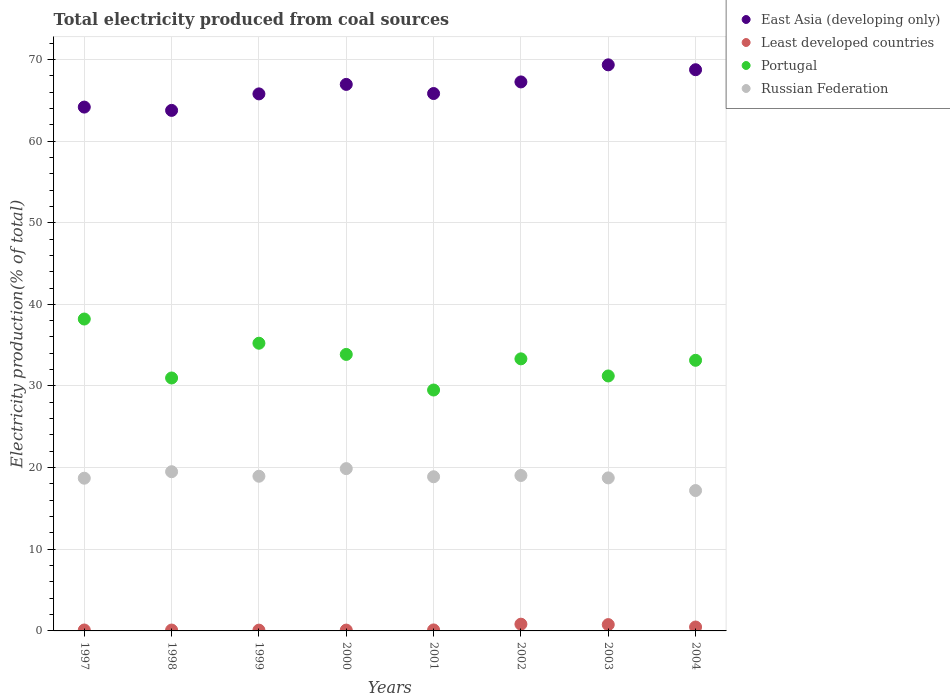How many different coloured dotlines are there?
Give a very brief answer. 4. What is the total electricity produced in Russian Federation in 2003?
Offer a terse response. 18.74. Across all years, what is the maximum total electricity produced in Russian Federation?
Your response must be concise. 19.88. Across all years, what is the minimum total electricity produced in Russian Federation?
Give a very brief answer. 17.19. In which year was the total electricity produced in Russian Federation maximum?
Make the answer very short. 2000. In which year was the total electricity produced in Portugal minimum?
Your response must be concise. 2001. What is the total total electricity produced in Portugal in the graph?
Your response must be concise. 265.48. What is the difference between the total electricity produced in Russian Federation in 1997 and that in 2001?
Ensure brevity in your answer.  -0.18. What is the difference between the total electricity produced in Portugal in 2002 and the total electricity produced in Russian Federation in 2000?
Provide a short and direct response. 13.45. What is the average total electricity produced in Least developed countries per year?
Give a very brief answer. 0.33. In the year 2000, what is the difference between the total electricity produced in East Asia (developing only) and total electricity produced in Least developed countries?
Provide a short and direct response. 66.84. In how many years, is the total electricity produced in Russian Federation greater than 66 %?
Give a very brief answer. 0. What is the ratio of the total electricity produced in Least developed countries in 2003 to that in 2004?
Your answer should be very brief. 1.62. What is the difference between the highest and the second highest total electricity produced in Least developed countries?
Offer a terse response. 0.05. What is the difference between the highest and the lowest total electricity produced in Portugal?
Offer a very short reply. 8.7. Is it the case that in every year, the sum of the total electricity produced in Least developed countries and total electricity produced in East Asia (developing only)  is greater than the sum of total electricity produced in Portugal and total electricity produced in Russian Federation?
Keep it short and to the point. Yes. Is it the case that in every year, the sum of the total electricity produced in East Asia (developing only) and total electricity produced in Portugal  is greater than the total electricity produced in Russian Federation?
Give a very brief answer. Yes. Does the total electricity produced in Portugal monotonically increase over the years?
Provide a short and direct response. No. Is the total electricity produced in Russian Federation strictly less than the total electricity produced in Portugal over the years?
Give a very brief answer. Yes. How many years are there in the graph?
Make the answer very short. 8. Are the values on the major ticks of Y-axis written in scientific E-notation?
Your answer should be compact. No. How are the legend labels stacked?
Give a very brief answer. Vertical. What is the title of the graph?
Provide a short and direct response. Total electricity produced from coal sources. Does "Niger" appear as one of the legend labels in the graph?
Offer a terse response. No. What is the label or title of the X-axis?
Offer a terse response. Years. What is the label or title of the Y-axis?
Give a very brief answer. Electricity production(% of total). What is the Electricity production(% of total) in East Asia (developing only) in 1997?
Offer a terse response. 64.16. What is the Electricity production(% of total) in Least developed countries in 1997?
Provide a short and direct response. 0.11. What is the Electricity production(% of total) of Portugal in 1997?
Offer a terse response. 38.2. What is the Electricity production(% of total) of Russian Federation in 1997?
Your answer should be very brief. 18.7. What is the Electricity production(% of total) in East Asia (developing only) in 1998?
Provide a short and direct response. 63.75. What is the Electricity production(% of total) of Least developed countries in 1998?
Ensure brevity in your answer.  0.11. What is the Electricity production(% of total) of Portugal in 1998?
Make the answer very short. 30.98. What is the Electricity production(% of total) of Russian Federation in 1998?
Ensure brevity in your answer.  19.5. What is the Electricity production(% of total) of East Asia (developing only) in 1999?
Ensure brevity in your answer.  65.77. What is the Electricity production(% of total) in Least developed countries in 1999?
Offer a very short reply. 0.1. What is the Electricity production(% of total) in Portugal in 1999?
Your answer should be compact. 35.24. What is the Electricity production(% of total) in Russian Federation in 1999?
Your answer should be compact. 18.94. What is the Electricity production(% of total) in East Asia (developing only) in 2000?
Make the answer very short. 66.94. What is the Electricity production(% of total) of Least developed countries in 2000?
Keep it short and to the point. 0.1. What is the Electricity production(% of total) in Portugal in 2000?
Keep it short and to the point. 33.87. What is the Electricity production(% of total) of Russian Federation in 2000?
Provide a succinct answer. 19.88. What is the Electricity production(% of total) in East Asia (developing only) in 2001?
Offer a very short reply. 65.82. What is the Electricity production(% of total) in Least developed countries in 2001?
Make the answer very short. 0.12. What is the Electricity production(% of total) of Portugal in 2001?
Provide a succinct answer. 29.51. What is the Electricity production(% of total) in Russian Federation in 2001?
Your answer should be compact. 18.88. What is the Electricity production(% of total) in East Asia (developing only) in 2002?
Keep it short and to the point. 67.24. What is the Electricity production(% of total) in Least developed countries in 2002?
Make the answer very short. 0.83. What is the Electricity production(% of total) of Portugal in 2002?
Offer a very short reply. 33.32. What is the Electricity production(% of total) in Russian Federation in 2002?
Make the answer very short. 19.04. What is the Electricity production(% of total) of East Asia (developing only) in 2003?
Make the answer very short. 69.33. What is the Electricity production(% of total) of Least developed countries in 2003?
Ensure brevity in your answer.  0.77. What is the Electricity production(% of total) of Portugal in 2003?
Your response must be concise. 31.23. What is the Electricity production(% of total) in Russian Federation in 2003?
Your answer should be compact. 18.74. What is the Electricity production(% of total) of East Asia (developing only) in 2004?
Provide a short and direct response. 68.73. What is the Electricity production(% of total) of Least developed countries in 2004?
Offer a very short reply. 0.48. What is the Electricity production(% of total) in Portugal in 2004?
Make the answer very short. 33.15. What is the Electricity production(% of total) of Russian Federation in 2004?
Provide a short and direct response. 17.19. Across all years, what is the maximum Electricity production(% of total) of East Asia (developing only)?
Your answer should be very brief. 69.33. Across all years, what is the maximum Electricity production(% of total) of Least developed countries?
Give a very brief answer. 0.83. Across all years, what is the maximum Electricity production(% of total) in Portugal?
Your answer should be compact. 38.2. Across all years, what is the maximum Electricity production(% of total) of Russian Federation?
Ensure brevity in your answer.  19.88. Across all years, what is the minimum Electricity production(% of total) of East Asia (developing only)?
Your answer should be compact. 63.75. Across all years, what is the minimum Electricity production(% of total) of Least developed countries?
Make the answer very short. 0.1. Across all years, what is the minimum Electricity production(% of total) of Portugal?
Your answer should be very brief. 29.51. Across all years, what is the minimum Electricity production(% of total) in Russian Federation?
Provide a short and direct response. 17.19. What is the total Electricity production(% of total) of East Asia (developing only) in the graph?
Provide a short and direct response. 531.75. What is the total Electricity production(% of total) of Least developed countries in the graph?
Your answer should be very brief. 2.62. What is the total Electricity production(% of total) in Portugal in the graph?
Ensure brevity in your answer.  265.48. What is the total Electricity production(% of total) in Russian Federation in the graph?
Keep it short and to the point. 150.88. What is the difference between the Electricity production(% of total) of East Asia (developing only) in 1997 and that in 1998?
Provide a succinct answer. 0.4. What is the difference between the Electricity production(% of total) of Least developed countries in 1997 and that in 1998?
Make the answer very short. 0.01. What is the difference between the Electricity production(% of total) in Portugal in 1997 and that in 1998?
Ensure brevity in your answer.  7.22. What is the difference between the Electricity production(% of total) of Russian Federation in 1997 and that in 1998?
Provide a succinct answer. -0.79. What is the difference between the Electricity production(% of total) of East Asia (developing only) in 1997 and that in 1999?
Your response must be concise. -1.62. What is the difference between the Electricity production(% of total) in Least developed countries in 1997 and that in 1999?
Ensure brevity in your answer.  0.02. What is the difference between the Electricity production(% of total) in Portugal in 1997 and that in 1999?
Offer a terse response. 2.96. What is the difference between the Electricity production(% of total) in Russian Federation in 1997 and that in 1999?
Offer a very short reply. -0.24. What is the difference between the Electricity production(% of total) of East Asia (developing only) in 1997 and that in 2000?
Offer a very short reply. -2.78. What is the difference between the Electricity production(% of total) in Least developed countries in 1997 and that in 2000?
Give a very brief answer. 0.01. What is the difference between the Electricity production(% of total) of Portugal in 1997 and that in 2000?
Provide a succinct answer. 4.34. What is the difference between the Electricity production(% of total) of Russian Federation in 1997 and that in 2000?
Give a very brief answer. -1.17. What is the difference between the Electricity production(% of total) in East Asia (developing only) in 1997 and that in 2001?
Your answer should be very brief. -1.66. What is the difference between the Electricity production(% of total) of Least developed countries in 1997 and that in 2001?
Your response must be concise. -0.01. What is the difference between the Electricity production(% of total) in Portugal in 1997 and that in 2001?
Give a very brief answer. 8.7. What is the difference between the Electricity production(% of total) of Russian Federation in 1997 and that in 2001?
Your answer should be very brief. -0.18. What is the difference between the Electricity production(% of total) of East Asia (developing only) in 1997 and that in 2002?
Give a very brief answer. -3.08. What is the difference between the Electricity production(% of total) in Least developed countries in 1997 and that in 2002?
Offer a terse response. -0.71. What is the difference between the Electricity production(% of total) of Portugal in 1997 and that in 2002?
Keep it short and to the point. 4.88. What is the difference between the Electricity production(% of total) of Russian Federation in 1997 and that in 2002?
Keep it short and to the point. -0.33. What is the difference between the Electricity production(% of total) of East Asia (developing only) in 1997 and that in 2003?
Your answer should be compact. -5.17. What is the difference between the Electricity production(% of total) of Least developed countries in 1997 and that in 2003?
Your answer should be very brief. -0.66. What is the difference between the Electricity production(% of total) of Portugal in 1997 and that in 2003?
Your answer should be compact. 6.97. What is the difference between the Electricity production(% of total) in Russian Federation in 1997 and that in 2003?
Provide a succinct answer. -0.04. What is the difference between the Electricity production(% of total) of East Asia (developing only) in 1997 and that in 2004?
Keep it short and to the point. -4.58. What is the difference between the Electricity production(% of total) in Least developed countries in 1997 and that in 2004?
Give a very brief answer. -0.36. What is the difference between the Electricity production(% of total) of Portugal in 1997 and that in 2004?
Offer a terse response. 5.06. What is the difference between the Electricity production(% of total) of Russian Federation in 1997 and that in 2004?
Provide a short and direct response. 1.51. What is the difference between the Electricity production(% of total) of East Asia (developing only) in 1998 and that in 1999?
Your answer should be very brief. -2.02. What is the difference between the Electricity production(% of total) in Least developed countries in 1998 and that in 1999?
Your response must be concise. 0.01. What is the difference between the Electricity production(% of total) of Portugal in 1998 and that in 1999?
Make the answer very short. -4.26. What is the difference between the Electricity production(% of total) in Russian Federation in 1998 and that in 1999?
Provide a succinct answer. 0.55. What is the difference between the Electricity production(% of total) in East Asia (developing only) in 1998 and that in 2000?
Offer a very short reply. -3.18. What is the difference between the Electricity production(% of total) in Least developed countries in 1998 and that in 2000?
Offer a very short reply. 0. What is the difference between the Electricity production(% of total) in Portugal in 1998 and that in 2000?
Your response must be concise. -2.89. What is the difference between the Electricity production(% of total) in Russian Federation in 1998 and that in 2000?
Offer a very short reply. -0.38. What is the difference between the Electricity production(% of total) of East Asia (developing only) in 1998 and that in 2001?
Provide a succinct answer. -2.07. What is the difference between the Electricity production(% of total) of Least developed countries in 1998 and that in 2001?
Your response must be concise. -0.02. What is the difference between the Electricity production(% of total) of Portugal in 1998 and that in 2001?
Ensure brevity in your answer.  1.47. What is the difference between the Electricity production(% of total) in Russian Federation in 1998 and that in 2001?
Provide a succinct answer. 0.62. What is the difference between the Electricity production(% of total) of East Asia (developing only) in 1998 and that in 2002?
Your response must be concise. -3.49. What is the difference between the Electricity production(% of total) of Least developed countries in 1998 and that in 2002?
Your answer should be compact. -0.72. What is the difference between the Electricity production(% of total) of Portugal in 1998 and that in 2002?
Provide a succinct answer. -2.34. What is the difference between the Electricity production(% of total) of Russian Federation in 1998 and that in 2002?
Provide a succinct answer. 0.46. What is the difference between the Electricity production(% of total) of East Asia (developing only) in 1998 and that in 2003?
Your answer should be compact. -5.58. What is the difference between the Electricity production(% of total) of Least developed countries in 1998 and that in 2003?
Offer a terse response. -0.67. What is the difference between the Electricity production(% of total) in Portugal in 1998 and that in 2003?
Provide a succinct answer. -0.25. What is the difference between the Electricity production(% of total) in Russian Federation in 1998 and that in 2003?
Offer a very short reply. 0.76. What is the difference between the Electricity production(% of total) of East Asia (developing only) in 1998 and that in 2004?
Your answer should be compact. -4.98. What is the difference between the Electricity production(% of total) of Least developed countries in 1998 and that in 2004?
Make the answer very short. -0.37. What is the difference between the Electricity production(% of total) in Portugal in 1998 and that in 2004?
Your response must be concise. -2.17. What is the difference between the Electricity production(% of total) in Russian Federation in 1998 and that in 2004?
Your answer should be compact. 2.31. What is the difference between the Electricity production(% of total) in East Asia (developing only) in 1999 and that in 2000?
Your answer should be very brief. -1.16. What is the difference between the Electricity production(% of total) of Least developed countries in 1999 and that in 2000?
Your answer should be compact. -0.01. What is the difference between the Electricity production(% of total) in Portugal in 1999 and that in 2000?
Give a very brief answer. 1.37. What is the difference between the Electricity production(% of total) in Russian Federation in 1999 and that in 2000?
Offer a terse response. -0.93. What is the difference between the Electricity production(% of total) of East Asia (developing only) in 1999 and that in 2001?
Give a very brief answer. -0.04. What is the difference between the Electricity production(% of total) of Least developed countries in 1999 and that in 2001?
Your answer should be very brief. -0.02. What is the difference between the Electricity production(% of total) in Portugal in 1999 and that in 2001?
Make the answer very short. 5.73. What is the difference between the Electricity production(% of total) in Russian Federation in 1999 and that in 2001?
Make the answer very short. 0.06. What is the difference between the Electricity production(% of total) in East Asia (developing only) in 1999 and that in 2002?
Offer a terse response. -1.47. What is the difference between the Electricity production(% of total) in Least developed countries in 1999 and that in 2002?
Offer a very short reply. -0.73. What is the difference between the Electricity production(% of total) in Portugal in 1999 and that in 2002?
Provide a succinct answer. 1.91. What is the difference between the Electricity production(% of total) of Russian Federation in 1999 and that in 2002?
Give a very brief answer. -0.09. What is the difference between the Electricity production(% of total) of East Asia (developing only) in 1999 and that in 2003?
Provide a succinct answer. -3.56. What is the difference between the Electricity production(% of total) in Least developed countries in 1999 and that in 2003?
Your response must be concise. -0.68. What is the difference between the Electricity production(% of total) of Portugal in 1999 and that in 2003?
Offer a terse response. 4.01. What is the difference between the Electricity production(% of total) in Russian Federation in 1999 and that in 2003?
Provide a succinct answer. 0.2. What is the difference between the Electricity production(% of total) of East Asia (developing only) in 1999 and that in 2004?
Your response must be concise. -2.96. What is the difference between the Electricity production(% of total) of Least developed countries in 1999 and that in 2004?
Offer a very short reply. -0.38. What is the difference between the Electricity production(% of total) in Portugal in 1999 and that in 2004?
Your answer should be compact. 2.09. What is the difference between the Electricity production(% of total) of Russian Federation in 1999 and that in 2004?
Offer a terse response. 1.75. What is the difference between the Electricity production(% of total) of East Asia (developing only) in 2000 and that in 2001?
Offer a terse response. 1.12. What is the difference between the Electricity production(% of total) in Least developed countries in 2000 and that in 2001?
Your response must be concise. -0.02. What is the difference between the Electricity production(% of total) of Portugal in 2000 and that in 2001?
Offer a very short reply. 4.36. What is the difference between the Electricity production(% of total) in Russian Federation in 2000 and that in 2001?
Provide a short and direct response. 1. What is the difference between the Electricity production(% of total) of East Asia (developing only) in 2000 and that in 2002?
Make the answer very short. -0.3. What is the difference between the Electricity production(% of total) of Least developed countries in 2000 and that in 2002?
Ensure brevity in your answer.  -0.72. What is the difference between the Electricity production(% of total) of Portugal in 2000 and that in 2002?
Keep it short and to the point. 0.54. What is the difference between the Electricity production(% of total) in Russian Federation in 2000 and that in 2002?
Your answer should be compact. 0.84. What is the difference between the Electricity production(% of total) in East Asia (developing only) in 2000 and that in 2003?
Offer a very short reply. -2.4. What is the difference between the Electricity production(% of total) in Least developed countries in 2000 and that in 2003?
Your answer should be very brief. -0.67. What is the difference between the Electricity production(% of total) of Portugal in 2000 and that in 2003?
Provide a succinct answer. 2.64. What is the difference between the Electricity production(% of total) in Russian Federation in 2000 and that in 2003?
Give a very brief answer. 1.14. What is the difference between the Electricity production(% of total) in East Asia (developing only) in 2000 and that in 2004?
Give a very brief answer. -1.8. What is the difference between the Electricity production(% of total) in Least developed countries in 2000 and that in 2004?
Offer a terse response. -0.38. What is the difference between the Electricity production(% of total) of Portugal in 2000 and that in 2004?
Provide a short and direct response. 0.72. What is the difference between the Electricity production(% of total) of Russian Federation in 2000 and that in 2004?
Provide a succinct answer. 2.68. What is the difference between the Electricity production(% of total) in East Asia (developing only) in 2001 and that in 2002?
Provide a succinct answer. -1.42. What is the difference between the Electricity production(% of total) of Least developed countries in 2001 and that in 2002?
Give a very brief answer. -0.71. What is the difference between the Electricity production(% of total) in Portugal in 2001 and that in 2002?
Your answer should be compact. -3.82. What is the difference between the Electricity production(% of total) in Russian Federation in 2001 and that in 2002?
Your response must be concise. -0.16. What is the difference between the Electricity production(% of total) in East Asia (developing only) in 2001 and that in 2003?
Offer a very short reply. -3.51. What is the difference between the Electricity production(% of total) of Least developed countries in 2001 and that in 2003?
Offer a terse response. -0.65. What is the difference between the Electricity production(% of total) of Portugal in 2001 and that in 2003?
Offer a very short reply. -1.72. What is the difference between the Electricity production(% of total) in Russian Federation in 2001 and that in 2003?
Your answer should be compact. 0.14. What is the difference between the Electricity production(% of total) in East Asia (developing only) in 2001 and that in 2004?
Offer a terse response. -2.91. What is the difference between the Electricity production(% of total) in Least developed countries in 2001 and that in 2004?
Offer a terse response. -0.36. What is the difference between the Electricity production(% of total) of Portugal in 2001 and that in 2004?
Provide a short and direct response. -3.64. What is the difference between the Electricity production(% of total) in Russian Federation in 2001 and that in 2004?
Provide a succinct answer. 1.69. What is the difference between the Electricity production(% of total) in East Asia (developing only) in 2002 and that in 2003?
Ensure brevity in your answer.  -2.09. What is the difference between the Electricity production(% of total) in Least developed countries in 2002 and that in 2003?
Your answer should be compact. 0.05. What is the difference between the Electricity production(% of total) of Portugal in 2002 and that in 2003?
Offer a terse response. 2.1. What is the difference between the Electricity production(% of total) in Russian Federation in 2002 and that in 2003?
Offer a terse response. 0.3. What is the difference between the Electricity production(% of total) in East Asia (developing only) in 2002 and that in 2004?
Your answer should be compact. -1.49. What is the difference between the Electricity production(% of total) in Least developed countries in 2002 and that in 2004?
Your answer should be very brief. 0.35. What is the difference between the Electricity production(% of total) of Portugal in 2002 and that in 2004?
Give a very brief answer. 0.18. What is the difference between the Electricity production(% of total) in Russian Federation in 2002 and that in 2004?
Ensure brevity in your answer.  1.85. What is the difference between the Electricity production(% of total) of East Asia (developing only) in 2003 and that in 2004?
Provide a succinct answer. 0.6. What is the difference between the Electricity production(% of total) of Least developed countries in 2003 and that in 2004?
Your answer should be compact. 0.3. What is the difference between the Electricity production(% of total) in Portugal in 2003 and that in 2004?
Offer a very short reply. -1.92. What is the difference between the Electricity production(% of total) in Russian Federation in 2003 and that in 2004?
Your response must be concise. 1.55. What is the difference between the Electricity production(% of total) of East Asia (developing only) in 1997 and the Electricity production(% of total) of Least developed countries in 1998?
Offer a very short reply. 64.05. What is the difference between the Electricity production(% of total) in East Asia (developing only) in 1997 and the Electricity production(% of total) in Portugal in 1998?
Give a very brief answer. 33.18. What is the difference between the Electricity production(% of total) of East Asia (developing only) in 1997 and the Electricity production(% of total) of Russian Federation in 1998?
Your answer should be very brief. 44.66. What is the difference between the Electricity production(% of total) of Least developed countries in 1997 and the Electricity production(% of total) of Portugal in 1998?
Your response must be concise. -30.87. What is the difference between the Electricity production(% of total) of Least developed countries in 1997 and the Electricity production(% of total) of Russian Federation in 1998?
Ensure brevity in your answer.  -19.39. What is the difference between the Electricity production(% of total) of Portugal in 1997 and the Electricity production(% of total) of Russian Federation in 1998?
Your answer should be compact. 18.7. What is the difference between the Electricity production(% of total) of East Asia (developing only) in 1997 and the Electricity production(% of total) of Least developed countries in 1999?
Keep it short and to the point. 64.06. What is the difference between the Electricity production(% of total) in East Asia (developing only) in 1997 and the Electricity production(% of total) in Portugal in 1999?
Your answer should be very brief. 28.92. What is the difference between the Electricity production(% of total) of East Asia (developing only) in 1997 and the Electricity production(% of total) of Russian Federation in 1999?
Make the answer very short. 45.21. What is the difference between the Electricity production(% of total) in Least developed countries in 1997 and the Electricity production(% of total) in Portugal in 1999?
Make the answer very short. -35.12. What is the difference between the Electricity production(% of total) of Least developed countries in 1997 and the Electricity production(% of total) of Russian Federation in 1999?
Offer a terse response. -18.83. What is the difference between the Electricity production(% of total) in Portugal in 1997 and the Electricity production(% of total) in Russian Federation in 1999?
Provide a short and direct response. 19.26. What is the difference between the Electricity production(% of total) of East Asia (developing only) in 1997 and the Electricity production(% of total) of Least developed countries in 2000?
Your answer should be compact. 64.06. What is the difference between the Electricity production(% of total) in East Asia (developing only) in 1997 and the Electricity production(% of total) in Portugal in 2000?
Ensure brevity in your answer.  30.29. What is the difference between the Electricity production(% of total) in East Asia (developing only) in 1997 and the Electricity production(% of total) in Russian Federation in 2000?
Give a very brief answer. 44.28. What is the difference between the Electricity production(% of total) in Least developed countries in 1997 and the Electricity production(% of total) in Portugal in 2000?
Your answer should be compact. -33.75. What is the difference between the Electricity production(% of total) in Least developed countries in 1997 and the Electricity production(% of total) in Russian Federation in 2000?
Your answer should be very brief. -19.76. What is the difference between the Electricity production(% of total) in Portugal in 1997 and the Electricity production(% of total) in Russian Federation in 2000?
Ensure brevity in your answer.  18.32. What is the difference between the Electricity production(% of total) in East Asia (developing only) in 1997 and the Electricity production(% of total) in Least developed countries in 2001?
Make the answer very short. 64.04. What is the difference between the Electricity production(% of total) of East Asia (developing only) in 1997 and the Electricity production(% of total) of Portugal in 2001?
Offer a terse response. 34.65. What is the difference between the Electricity production(% of total) in East Asia (developing only) in 1997 and the Electricity production(% of total) in Russian Federation in 2001?
Make the answer very short. 45.28. What is the difference between the Electricity production(% of total) of Least developed countries in 1997 and the Electricity production(% of total) of Portugal in 2001?
Your response must be concise. -29.39. What is the difference between the Electricity production(% of total) of Least developed countries in 1997 and the Electricity production(% of total) of Russian Federation in 2001?
Provide a short and direct response. -18.77. What is the difference between the Electricity production(% of total) of Portugal in 1997 and the Electricity production(% of total) of Russian Federation in 2001?
Offer a very short reply. 19.32. What is the difference between the Electricity production(% of total) in East Asia (developing only) in 1997 and the Electricity production(% of total) in Least developed countries in 2002?
Your answer should be compact. 63.33. What is the difference between the Electricity production(% of total) in East Asia (developing only) in 1997 and the Electricity production(% of total) in Portugal in 2002?
Offer a terse response. 30.84. What is the difference between the Electricity production(% of total) in East Asia (developing only) in 1997 and the Electricity production(% of total) in Russian Federation in 2002?
Offer a very short reply. 45.12. What is the difference between the Electricity production(% of total) in Least developed countries in 1997 and the Electricity production(% of total) in Portugal in 2002?
Provide a succinct answer. -33.21. What is the difference between the Electricity production(% of total) of Least developed countries in 1997 and the Electricity production(% of total) of Russian Federation in 2002?
Your answer should be compact. -18.93. What is the difference between the Electricity production(% of total) of Portugal in 1997 and the Electricity production(% of total) of Russian Federation in 2002?
Your answer should be very brief. 19.16. What is the difference between the Electricity production(% of total) in East Asia (developing only) in 1997 and the Electricity production(% of total) in Least developed countries in 2003?
Offer a very short reply. 63.38. What is the difference between the Electricity production(% of total) of East Asia (developing only) in 1997 and the Electricity production(% of total) of Portugal in 2003?
Offer a very short reply. 32.93. What is the difference between the Electricity production(% of total) in East Asia (developing only) in 1997 and the Electricity production(% of total) in Russian Federation in 2003?
Offer a very short reply. 45.42. What is the difference between the Electricity production(% of total) in Least developed countries in 1997 and the Electricity production(% of total) in Portugal in 2003?
Your answer should be compact. -31.11. What is the difference between the Electricity production(% of total) in Least developed countries in 1997 and the Electricity production(% of total) in Russian Federation in 2003?
Provide a succinct answer. -18.63. What is the difference between the Electricity production(% of total) in Portugal in 1997 and the Electricity production(% of total) in Russian Federation in 2003?
Provide a short and direct response. 19.46. What is the difference between the Electricity production(% of total) of East Asia (developing only) in 1997 and the Electricity production(% of total) of Least developed countries in 2004?
Offer a terse response. 63.68. What is the difference between the Electricity production(% of total) of East Asia (developing only) in 1997 and the Electricity production(% of total) of Portugal in 2004?
Provide a succinct answer. 31.01. What is the difference between the Electricity production(% of total) in East Asia (developing only) in 1997 and the Electricity production(% of total) in Russian Federation in 2004?
Make the answer very short. 46.97. What is the difference between the Electricity production(% of total) of Least developed countries in 1997 and the Electricity production(% of total) of Portugal in 2004?
Offer a terse response. -33.03. What is the difference between the Electricity production(% of total) of Least developed countries in 1997 and the Electricity production(% of total) of Russian Federation in 2004?
Offer a very short reply. -17.08. What is the difference between the Electricity production(% of total) of Portugal in 1997 and the Electricity production(% of total) of Russian Federation in 2004?
Provide a succinct answer. 21.01. What is the difference between the Electricity production(% of total) of East Asia (developing only) in 1998 and the Electricity production(% of total) of Least developed countries in 1999?
Your answer should be very brief. 63.66. What is the difference between the Electricity production(% of total) of East Asia (developing only) in 1998 and the Electricity production(% of total) of Portugal in 1999?
Keep it short and to the point. 28.52. What is the difference between the Electricity production(% of total) in East Asia (developing only) in 1998 and the Electricity production(% of total) in Russian Federation in 1999?
Offer a terse response. 44.81. What is the difference between the Electricity production(% of total) in Least developed countries in 1998 and the Electricity production(% of total) in Portugal in 1999?
Ensure brevity in your answer.  -35.13. What is the difference between the Electricity production(% of total) of Least developed countries in 1998 and the Electricity production(% of total) of Russian Federation in 1999?
Offer a terse response. -18.84. What is the difference between the Electricity production(% of total) in Portugal in 1998 and the Electricity production(% of total) in Russian Federation in 1999?
Your answer should be compact. 12.03. What is the difference between the Electricity production(% of total) of East Asia (developing only) in 1998 and the Electricity production(% of total) of Least developed countries in 2000?
Ensure brevity in your answer.  63.65. What is the difference between the Electricity production(% of total) in East Asia (developing only) in 1998 and the Electricity production(% of total) in Portugal in 2000?
Your answer should be very brief. 29.89. What is the difference between the Electricity production(% of total) in East Asia (developing only) in 1998 and the Electricity production(% of total) in Russian Federation in 2000?
Your answer should be very brief. 43.88. What is the difference between the Electricity production(% of total) in Least developed countries in 1998 and the Electricity production(% of total) in Portugal in 2000?
Keep it short and to the point. -33.76. What is the difference between the Electricity production(% of total) of Least developed countries in 1998 and the Electricity production(% of total) of Russian Federation in 2000?
Provide a succinct answer. -19.77. What is the difference between the Electricity production(% of total) in Portugal in 1998 and the Electricity production(% of total) in Russian Federation in 2000?
Make the answer very short. 11.1. What is the difference between the Electricity production(% of total) in East Asia (developing only) in 1998 and the Electricity production(% of total) in Least developed countries in 2001?
Offer a very short reply. 63.63. What is the difference between the Electricity production(% of total) of East Asia (developing only) in 1998 and the Electricity production(% of total) of Portugal in 2001?
Offer a very short reply. 34.25. What is the difference between the Electricity production(% of total) in East Asia (developing only) in 1998 and the Electricity production(% of total) in Russian Federation in 2001?
Provide a short and direct response. 44.87. What is the difference between the Electricity production(% of total) of Least developed countries in 1998 and the Electricity production(% of total) of Portugal in 2001?
Your answer should be very brief. -29.4. What is the difference between the Electricity production(% of total) of Least developed countries in 1998 and the Electricity production(% of total) of Russian Federation in 2001?
Ensure brevity in your answer.  -18.78. What is the difference between the Electricity production(% of total) of Portugal in 1998 and the Electricity production(% of total) of Russian Federation in 2001?
Ensure brevity in your answer.  12.1. What is the difference between the Electricity production(% of total) in East Asia (developing only) in 1998 and the Electricity production(% of total) in Least developed countries in 2002?
Offer a very short reply. 62.93. What is the difference between the Electricity production(% of total) of East Asia (developing only) in 1998 and the Electricity production(% of total) of Portugal in 2002?
Your response must be concise. 30.43. What is the difference between the Electricity production(% of total) of East Asia (developing only) in 1998 and the Electricity production(% of total) of Russian Federation in 2002?
Make the answer very short. 44.71. What is the difference between the Electricity production(% of total) of Least developed countries in 1998 and the Electricity production(% of total) of Portugal in 2002?
Ensure brevity in your answer.  -33.22. What is the difference between the Electricity production(% of total) in Least developed countries in 1998 and the Electricity production(% of total) in Russian Federation in 2002?
Provide a succinct answer. -18.93. What is the difference between the Electricity production(% of total) of Portugal in 1998 and the Electricity production(% of total) of Russian Federation in 2002?
Ensure brevity in your answer.  11.94. What is the difference between the Electricity production(% of total) of East Asia (developing only) in 1998 and the Electricity production(% of total) of Least developed countries in 2003?
Make the answer very short. 62.98. What is the difference between the Electricity production(% of total) in East Asia (developing only) in 1998 and the Electricity production(% of total) in Portugal in 2003?
Provide a short and direct response. 32.53. What is the difference between the Electricity production(% of total) of East Asia (developing only) in 1998 and the Electricity production(% of total) of Russian Federation in 2003?
Provide a short and direct response. 45.01. What is the difference between the Electricity production(% of total) in Least developed countries in 1998 and the Electricity production(% of total) in Portugal in 2003?
Make the answer very short. -31.12. What is the difference between the Electricity production(% of total) in Least developed countries in 1998 and the Electricity production(% of total) in Russian Federation in 2003?
Give a very brief answer. -18.64. What is the difference between the Electricity production(% of total) of Portugal in 1998 and the Electricity production(% of total) of Russian Federation in 2003?
Your answer should be compact. 12.24. What is the difference between the Electricity production(% of total) of East Asia (developing only) in 1998 and the Electricity production(% of total) of Least developed countries in 2004?
Your response must be concise. 63.28. What is the difference between the Electricity production(% of total) of East Asia (developing only) in 1998 and the Electricity production(% of total) of Portugal in 2004?
Keep it short and to the point. 30.61. What is the difference between the Electricity production(% of total) in East Asia (developing only) in 1998 and the Electricity production(% of total) in Russian Federation in 2004?
Ensure brevity in your answer.  46.56. What is the difference between the Electricity production(% of total) of Least developed countries in 1998 and the Electricity production(% of total) of Portugal in 2004?
Keep it short and to the point. -33.04. What is the difference between the Electricity production(% of total) in Least developed countries in 1998 and the Electricity production(% of total) in Russian Federation in 2004?
Your response must be concise. -17.09. What is the difference between the Electricity production(% of total) in Portugal in 1998 and the Electricity production(% of total) in Russian Federation in 2004?
Ensure brevity in your answer.  13.79. What is the difference between the Electricity production(% of total) of East Asia (developing only) in 1999 and the Electricity production(% of total) of Least developed countries in 2000?
Provide a short and direct response. 65.67. What is the difference between the Electricity production(% of total) of East Asia (developing only) in 1999 and the Electricity production(% of total) of Portugal in 2000?
Keep it short and to the point. 31.91. What is the difference between the Electricity production(% of total) in East Asia (developing only) in 1999 and the Electricity production(% of total) in Russian Federation in 2000?
Provide a short and direct response. 45.9. What is the difference between the Electricity production(% of total) in Least developed countries in 1999 and the Electricity production(% of total) in Portugal in 2000?
Give a very brief answer. -33.77. What is the difference between the Electricity production(% of total) in Least developed countries in 1999 and the Electricity production(% of total) in Russian Federation in 2000?
Provide a short and direct response. -19.78. What is the difference between the Electricity production(% of total) of Portugal in 1999 and the Electricity production(% of total) of Russian Federation in 2000?
Provide a succinct answer. 15.36. What is the difference between the Electricity production(% of total) in East Asia (developing only) in 1999 and the Electricity production(% of total) in Least developed countries in 2001?
Offer a terse response. 65.65. What is the difference between the Electricity production(% of total) of East Asia (developing only) in 1999 and the Electricity production(% of total) of Portugal in 2001?
Your answer should be very brief. 36.27. What is the difference between the Electricity production(% of total) of East Asia (developing only) in 1999 and the Electricity production(% of total) of Russian Federation in 2001?
Offer a very short reply. 46.89. What is the difference between the Electricity production(% of total) of Least developed countries in 1999 and the Electricity production(% of total) of Portugal in 2001?
Your answer should be very brief. -29.41. What is the difference between the Electricity production(% of total) in Least developed countries in 1999 and the Electricity production(% of total) in Russian Federation in 2001?
Offer a very short reply. -18.79. What is the difference between the Electricity production(% of total) in Portugal in 1999 and the Electricity production(% of total) in Russian Federation in 2001?
Provide a short and direct response. 16.35. What is the difference between the Electricity production(% of total) of East Asia (developing only) in 1999 and the Electricity production(% of total) of Least developed countries in 2002?
Provide a succinct answer. 64.95. What is the difference between the Electricity production(% of total) of East Asia (developing only) in 1999 and the Electricity production(% of total) of Portugal in 2002?
Give a very brief answer. 32.45. What is the difference between the Electricity production(% of total) in East Asia (developing only) in 1999 and the Electricity production(% of total) in Russian Federation in 2002?
Offer a terse response. 46.74. What is the difference between the Electricity production(% of total) of Least developed countries in 1999 and the Electricity production(% of total) of Portugal in 2002?
Your answer should be compact. -33.23. What is the difference between the Electricity production(% of total) in Least developed countries in 1999 and the Electricity production(% of total) in Russian Federation in 2002?
Provide a short and direct response. -18.94. What is the difference between the Electricity production(% of total) in Portugal in 1999 and the Electricity production(% of total) in Russian Federation in 2002?
Offer a very short reply. 16.2. What is the difference between the Electricity production(% of total) of East Asia (developing only) in 1999 and the Electricity production(% of total) of Least developed countries in 2003?
Ensure brevity in your answer.  65. What is the difference between the Electricity production(% of total) in East Asia (developing only) in 1999 and the Electricity production(% of total) in Portugal in 2003?
Keep it short and to the point. 34.55. What is the difference between the Electricity production(% of total) in East Asia (developing only) in 1999 and the Electricity production(% of total) in Russian Federation in 2003?
Offer a very short reply. 47.03. What is the difference between the Electricity production(% of total) in Least developed countries in 1999 and the Electricity production(% of total) in Portugal in 2003?
Make the answer very short. -31.13. What is the difference between the Electricity production(% of total) in Least developed countries in 1999 and the Electricity production(% of total) in Russian Federation in 2003?
Your answer should be compact. -18.64. What is the difference between the Electricity production(% of total) in Portugal in 1999 and the Electricity production(% of total) in Russian Federation in 2003?
Give a very brief answer. 16.49. What is the difference between the Electricity production(% of total) in East Asia (developing only) in 1999 and the Electricity production(% of total) in Least developed countries in 2004?
Your answer should be compact. 65.3. What is the difference between the Electricity production(% of total) in East Asia (developing only) in 1999 and the Electricity production(% of total) in Portugal in 2004?
Provide a short and direct response. 32.63. What is the difference between the Electricity production(% of total) of East Asia (developing only) in 1999 and the Electricity production(% of total) of Russian Federation in 2004?
Keep it short and to the point. 48.58. What is the difference between the Electricity production(% of total) in Least developed countries in 1999 and the Electricity production(% of total) in Portugal in 2004?
Make the answer very short. -33.05. What is the difference between the Electricity production(% of total) of Least developed countries in 1999 and the Electricity production(% of total) of Russian Federation in 2004?
Your response must be concise. -17.1. What is the difference between the Electricity production(% of total) in Portugal in 1999 and the Electricity production(% of total) in Russian Federation in 2004?
Make the answer very short. 18.04. What is the difference between the Electricity production(% of total) of East Asia (developing only) in 2000 and the Electricity production(% of total) of Least developed countries in 2001?
Keep it short and to the point. 66.82. What is the difference between the Electricity production(% of total) of East Asia (developing only) in 2000 and the Electricity production(% of total) of Portugal in 2001?
Your response must be concise. 37.43. What is the difference between the Electricity production(% of total) of East Asia (developing only) in 2000 and the Electricity production(% of total) of Russian Federation in 2001?
Make the answer very short. 48.05. What is the difference between the Electricity production(% of total) of Least developed countries in 2000 and the Electricity production(% of total) of Portugal in 2001?
Make the answer very short. -29.4. What is the difference between the Electricity production(% of total) of Least developed countries in 2000 and the Electricity production(% of total) of Russian Federation in 2001?
Give a very brief answer. -18.78. What is the difference between the Electricity production(% of total) in Portugal in 2000 and the Electricity production(% of total) in Russian Federation in 2001?
Provide a short and direct response. 14.98. What is the difference between the Electricity production(% of total) in East Asia (developing only) in 2000 and the Electricity production(% of total) in Least developed countries in 2002?
Give a very brief answer. 66.11. What is the difference between the Electricity production(% of total) of East Asia (developing only) in 2000 and the Electricity production(% of total) of Portugal in 2002?
Your answer should be compact. 33.61. What is the difference between the Electricity production(% of total) in East Asia (developing only) in 2000 and the Electricity production(% of total) in Russian Federation in 2002?
Provide a succinct answer. 47.9. What is the difference between the Electricity production(% of total) in Least developed countries in 2000 and the Electricity production(% of total) in Portugal in 2002?
Give a very brief answer. -33.22. What is the difference between the Electricity production(% of total) in Least developed countries in 2000 and the Electricity production(% of total) in Russian Federation in 2002?
Your response must be concise. -18.94. What is the difference between the Electricity production(% of total) of Portugal in 2000 and the Electricity production(% of total) of Russian Federation in 2002?
Your answer should be compact. 14.83. What is the difference between the Electricity production(% of total) in East Asia (developing only) in 2000 and the Electricity production(% of total) in Least developed countries in 2003?
Offer a terse response. 66.16. What is the difference between the Electricity production(% of total) of East Asia (developing only) in 2000 and the Electricity production(% of total) of Portugal in 2003?
Provide a short and direct response. 35.71. What is the difference between the Electricity production(% of total) in East Asia (developing only) in 2000 and the Electricity production(% of total) in Russian Federation in 2003?
Your response must be concise. 48.2. What is the difference between the Electricity production(% of total) of Least developed countries in 2000 and the Electricity production(% of total) of Portugal in 2003?
Provide a succinct answer. -31.13. What is the difference between the Electricity production(% of total) of Least developed countries in 2000 and the Electricity production(% of total) of Russian Federation in 2003?
Give a very brief answer. -18.64. What is the difference between the Electricity production(% of total) in Portugal in 2000 and the Electricity production(% of total) in Russian Federation in 2003?
Your answer should be very brief. 15.12. What is the difference between the Electricity production(% of total) in East Asia (developing only) in 2000 and the Electricity production(% of total) in Least developed countries in 2004?
Offer a terse response. 66.46. What is the difference between the Electricity production(% of total) in East Asia (developing only) in 2000 and the Electricity production(% of total) in Portugal in 2004?
Your response must be concise. 33.79. What is the difference between the Electricity production(% of total) of East Asia (developing only) in 2000 and the Electricity production(% of total) of Russian Federation in 2004?
Provide a succinct answer. 49.74. What is the difference between the Electricity production(% of total) of Least developed countries in 2000 and the Electricity production(% of total) of Portugal in 2004?
Ensure brevity in your answer.  -33.04. What is the difference between the Electricity production(% of total) of Least developed countries in 2000 and the Electricity production(% of total) of Russian Federation in 2004?
Offer a terse response. -17.09. What is the difference between the Electricity production(% of total) of Portugal in 2000 and the Electricity production(% of total) of Russian Federation in 2004?
Your answer should be compact. 16.67. What is the difference between the Electricity production(% of total) in East Asia (developing only) in 2001 and the Electricity production(% of total) in Least developed countries in 2002?
Offer a terse response. 64.99. What is the difference between the Electricity production(% of total) of East Asia (developing only) in 2001 and the Electricity production(% of total) of Portugal in 2002?
Provide a succinct answer. 32.5. What is the difference between the Electricity production(% of total) in East Asia (developing only) in 2001 and the Electricity production(% of total) in Russian Federation in 2002?
Offer a very short reply. 46.78. What is the difference between the Electricity production(% of total) in Least developed countries in 2001 and the Electricity production(% of total) in Portugal in 2002?
Your answer should be very brief. -33.2. What is the difference between the Electricity production(% of total) in Least developed countries in 2001 and the Electricity production(% of total) in Russian Federation in 2002?
Give a very brief answer. -18.92. What is the difference between the Electricity production(% of total) in Portugal in 2001 and the Electricity production(% of total) in Russian Federation in 2002?
Give a very brief answer. 10.47. What is the difference between the Electricity production(% of total) of East Asia (developing only) in 2001 and the Electricity production(% of total) of Least developed countries in 2003?
Keep it short and to the point. 65.05. What is the difference between the Electricity production(% of total) in East Asia (developing only) in 2001 and the Electricity production(% of total) in Portugal in 2003?
Your answer should be compact. 34.59. What is the difference between the Electricity production(% of total) of East Asia (developing only) in 2001 and the Electricity production(% of total) of Russian Federation in 2003?
Make the answer very short. 47.08. What is the difference between the Electricity production(% of total) of Least developed countries in 2001 and the Electricity production(% of total) of Portugal in 2003?
Provide a short and direct response. -31.11. What is the difference between the Electricity production(% of total) in Least developed countries in 2001 and the Electricity production(% of total) in Russian Federation in 2003?
Offer a terse response. -18.62. What is the difference between the Electricity production(% of total) in Portugal in 2001 and the Electricity production(% of total) in Russian Federation in 2003?
Your answer should be compact. 10.76. What is the difference between the Electricity production(% of total) of East Asia (developing only) in 2001 and the Electricity production(% of total) of Least developed countries in 2004?
Your answer should be compact. 65.34. What is the difference between the Electricity production(% of total) in East Asia (developing only) in 2001 and the Electricity production(% of total) in Portugal in 2004?
Provide a short and direct response. 32.67. What is the difference between the Electricity production(% of total) of East Asia (developing only) in 2001 and the Electricity production(% of total) of Russian Federation in 2004?
Your answer should be compact. 48.63. What is the difference between the Electricity production(% of total) of Least developed countries in 2001 and the Electricity production(% of total) of Portugal in 2004?
Provide a succinct answer. -33.02. What is the difference between the Electricity production(% of total) in Least developed countries in 2001 and the Electricity production(% of total) in Russian Federation in 2004?
Provide a succinct answer. -17.07. What is the difference between the Electricity production(% of total) in Portugal in 2001 and the Electricity production(% of total) in Russian Federation in 2004?
Ensure brevity in your answer.  12.31. What is the difference between the Electricity production(% of total) of East Asia (developing only) in 2002 and the Electricity production(% of total) of Least developed countries in 2003?
Your answer should be compact. 66.47. What is the difference between the Electricity production(% of total) in East Asia (developing only) in 2002 and the Electricity production(% of total) in Portugal in 2003?
Ensure brevity in your answer.  36.01. What is the difference between the Electricity production(% of total) of East Asia (developing only) in 2002 and the Electricity production(% of total) of Russian Federation in 2003?
Keep it short and to the point. 48.5. What is the difference between the Electricity production(% of total) in Least developed countries in 2002 and the Electricity production(% of total) in Portugal in 2003?
Offer a very short reply. -30.4. What is the difference between the Electricity production(% of total) of Least developed countries in 2002 and the Electricity production(% of total) of Russian Federation in 2003?
Provide a short and direct response. -17.92. What is the difference between the Electricity production(% of total) in Portugal in 2002 and the Electricity production(% of total) in Russian Federation in 2003?
Ensure brevity in your answer.  14.58. What is the difference between the Electricity production(% of total) of East Asia (developing only) in 2002 and the Electricity production(% of total) of Least developed countries in 2004?
Your answer should be very brief. 66.76. What is the difference between the Electricity production(% of total) in East Asia (developing only) in 2002 and the Electricity production(% of total) in Portugal in 2004?
Your response must be concise. 34.09. What is the difference between the Electricity production(% of total) of East Asia (developing only) in 2002 and the Electricity production(% of total) of Russian Federation in 2004?
Offer a very short reply. 50.05. What is the difference between the Electricity production(% of total) of Least developed countries in 2002 and the Electricity production(% of total) of Portugal in 2004?
Offer a very short reply. -32.32. What is the difference between the Electricity production(% of total) of Least developed countries in 2002 and the Electricity production(% of total) of Russian Federation in 2004?
Provide a short and direct response. -16.37. What is the difference between the Electricity production(% of total) in Portugal in 2002 and the Electricity production(% of total) in Russian Federation in 2004?
Your answer should be very brief. 16.13. What is the difference between the Electricity production(% of total) in East Asia (developing only) in 2003 and the Electricity production(% of total) in Least developed countries in 2004?
Give a very brief answer. 68.85. What is the difference between the Electricity production(% of total) of East Asia (developing only) in 2003 and the Electricity production(% of total) of Portugal in 2004?
Offer a very short reply. 36.19. What is the difference between the Electricity production(% of total) in East Asia (developing only) in 2003 and the Electricity production(% of total) in Russian Federation in 2004?
Ensure brevity in your answer.  52.14. What is the difference between the Electricity production(% of total) of Least developed countries in 2003 and the Electricity production(% of total) of Portugal in 2004?
Keep it short and to the point. -32.37. What is the difference between the Electricity production(% of total) in Least developed countries in 2003 and the Electricity production(% of total) in Russian Federation in 2004?
Provide a succinct answer. -16.42. What is the difference between the Electricity production(% of total) of Portugal in 2003 and the Electricity production(% of total) of Russian Federation in 2004?
Provide a short and direct response. 14.03. What is the average Electricity production(% of total) in East Asia (developing only) per year?
Offer a very short reply. 66.47. What is the average Electricity production(% of total) in Least developed countries per year?
Ensure brevity in your answer.  0.33. What is the average Electricity production(% of total) in Portugal per year?
Offer a very short reply. 33.19. What is the average Electricity production(% of total) in Russian Federation per year?
Your response must be concise. 18.86. In the year 1997, what is the difference between the Electricity production(% of total) of East Asia (developing only) and Electricity production(% of total) of Least developed countries?
Give a very brief answer. 64.05. In the year 1997, what is the difference between the Electricity production(% of total) of East Asia (developing only) and Electricity production(% of total) of Portugal?
Your answer should be very brief. 25.96. In the year 1997, what is the difference between the Electricity production(% of total) in East Asia (developing only) and Electricity production(% of total) in Russian Federation?
Provide a succinct answer. 45.45. In the year 1997, what is the difference between the Electricity production(% of total) of Least developed countries and Electricity production(% of total) of Portugal?
Provide a short and direct response. -38.09. In the year 1997, what is the difference between the Electricity production(% of total) of Least developed countries and Electricity production(% of total) of Russian Federation?
Your response must be concise. -18.59. In the year 1997, what is the difference between the Electricity production(% of total) of Portugal and Electricity production(% of total) of Russian Federation?
Make the answer very short. 19.5. In the year 1998, what is the difference between the Electricity production(% of total) in East Asia (developing only) and Electricity production(% of total) in Least developed countries?
Offer a very short reply. 63.65. In the year 1998, what is the difference between the Electricity production(% of total) in East Asia (developing only) and Electricity production(% of total) in Portugal?
Make the answer very short. 32.77. In the year 1998, what is the difference between the Electricity production(% of total) in East Asia (developing only) and Electricity production(% of total) in Russian Federation?
Your response must be concise. 44.25. In the year 1998, what is the difference between the Electricity production(% of total) of Least developed countries and Electricity production(% of total) of Portugal?
Offer a terse response. -30.87. In the year 1998, what is the difference between the Electricity production(% of total) of Least developed countries and Electricity production(% of total) of Russian Federation?
Make the answer very short. -19.39. In the year 1998, what is the difference between the Electricity production(% of total) in Portugal and Electricity production(% of total) in Russian Federation?
Make the answer very short. 11.48. In the year 1999, what is the difference between the Electricity production(% of total) in East Asia (developing only) and Electricity production(% of total) in Least developed countries?
Offer a terse response. 65.68. In the year 1999, what is the difference between the Electricity production(% of total) in East Asia (developing only) and Electricity production(% of total) in Portugal?
Ensure brevity in your answer.  30.54. In the year 1999, what is the difference between the Electricity production(% of total) of East Asia (developing only) and Electricity production(% of total) of Russian Federation?
Your response must be concise. 46.83. In the year 1999, what is the difference between the Electricity production(% of total) in Least developed countries and Electricity production(% of total) in Portugal?
Ensure brevity in your answer.  -35.14. In the year 1999, what is the difference between the Electricity production(% of total) of Least developed countries and Electricity production(% of total) of Russian Federation?
Offer a very short reply. -18.85. In the year 1999, what is the difference between the Electricity production(% of total) in Portugal and Electricity production(% of total) in Russian Federation?
Offer a very short reply. 16.29. In the year 2000, what is the difference between the Electricity production(% of total) of East Asia (developing only) and Electricity production(% of total) of Least developed countries?
Offer a very short reply. 66.83. In the year 2000, what is the difference between the Electricity production(% of total) of East Asia (developing only) and Electricity production(% of total) of Portugal?
Offer a very short reply. 33.07. In the year 2000, what is the difference between the Electricity production(% of total) of East Asia (developing only) and Electricity production(% of total) of Russian Federation?
Make the answer very short. 47.06. In the year 2000, what is the difference between the Electricity production(% of total) of Least developed countries and Electricity production(% of total) of Portugal?
Your answer should be compact. -33.76. In the year 2000, what is the difference between the Electricity production(% of total) in Least developed countries and Electricity production(% of total) in Russian Federation?
Provide a short and direct response. -19.78. In the year 2000, what is the difference between the Electricity production(% of total) of Portugal and Electricity production(% of total) of Russian Federation?
Provide a short and direct response. 13.99. In the year 2001, what is the difference between the Electricity production(% of total) of East Asia (developing only) and Electricity production(% of total) of Least developed countries?
Ensure brevity in your answer.  65.7. In the year 2001, what is the difference between the Electricity production(% of total) in East Asia (developing only) and Electricity production(% of total) in Portugal?
Offer a very short reply. 36.31. In the year 2001, what is the difference between the Electricity production(% of total) in East Asia (developing only) and Electricity production(% of total) in Russian Federation?
Offer a very short reply. 46.94. In the year 2001, what is the difference between the Electricity production(% of total) in Least developed countries and Electricity production(% of total) in Portugal?
Make the answer very short. -29.38. In the year 2001, what is the difference between the Electricity production(% of total) of Least developed countries and Electricity production(% of total) of Russian Federation?
Provide a short and direct response. -18.76. In the year 2001, what is the difference between the Electricity production(% of total) in Portugal and Electricity production(% of total) in Russian Federation?
Provide a short and direct response. 10.62. In the year 2002, what is the difference between the Electricity production(% of total) in East Asia (developing only) and Electricity production(% of total) in Least developed countries?
Offer a very short reply. 66.41. In the year 2002, what is the difference between the Electricity production(% of total) in East Asia (developing only) and Electricity production(% of total) in Portugal?
Your answer should be compact. 33.92. In the year 2002, what is the difference between the Electricity production(% of total) of East Asia (developing only) and Electricity production(% of total) of Russian Federation?
Your answer should be very brief. 48.2. In the year 2002, what is the difference between the Electricity production(% of total) in Least developed countries and Electricity production(% of total) in Portugal?
Give a very brief answer. -32.5. In the year 2002, what is the difference between the Electricity production(% of total) of Least developed countries and Electricity production(% of total) of Russian Federation?
Make the answer very short. -18.21. In the year 2002, what is the difference between the Electricity production(% of total) of Portugal and Electricity production(% of total) of Russian Federation?
Offer a very short reply. 14.28. In the year 2003, what is the difference between the Electricity production(% of total) of East Asia (developing only) and Electricity production(% of total) of Least developed countries?
Provide a succinct answer. 68.56. In the year 2003, what is the difference between the Electricity production(% of total) in East Asia (developing only) and Electricity production(% of total) in Portugal?
Your answer should be compact. 38.11. In the year 2003, what is the difference between the Electricity production(% of total) in East Asia (developing only) and Electricity production(% of total) in Russian Federation?
Provide a succinct answer. 50.59. In the year 2003, what is the difference between the Electricity production(% of total) of Least developed countries and Electricity production(% of total) of Portugal?
Offer a very short reply. -30.45. In the year 2003, what is the difference between the Electricity production(% of total) in Least developed countries and Electricity production(% of total) in Russian Federation?
Provide a succinct answer. -17.97. In the year 2003, what is the difference between the Electricity production(% of total) of Portugal and Electricity production(% of total) of Russian Federation?
Provide a succinct answer. 12.49. In the year 2004, what is the difference between the Electricity production(% of total) of East Asia (developing only) and Electricity production(% of total) of Least developed countries?
Give a very brief answer. 68.26. In the year 2004, what is the difference between the Electricity production(% of total) of East Asia (developing only) and Electricity production(% of total) of Portugal?
Your response must be concise. 35.59. In the year 2004, what is the difference between the Electricity production(% of total) of East Asia (developing only) and Electricity production(% of total) of Russian Federation?
Offer a terse response. 51.54. In the year 2004, what is the difference between the Electricity production(% of total) in Least developed countries and Electricity production(% of total) in Portugal?
Offer a terse response. -32.67. In the year 2004, what is the difference between the Electricity production(% of total) in Least developed countries and Electricity production(% of total) in Russian Federation?
Provide a succinct answer. -16.71. In the year 2004, what is the difference between the Electricity production(% of total) of Portugal and Electricity production(% of total) of Russian Federation?
Your response must be concise. 15.95. What is the ratio of the Electricity production(% of total) in East Asia (developing only) in 1997 to that in 1998?
Give a very brief answer. 1.01. What is the ratio of the Electricity production(% of total) in Least developed countries in 1997 to that in 1998?
Provide a short and direct response. 1.07. What is the ratio of the Electricity production(% of total) in Portugal in 1997 to that in 1998?
Your answer should be very brief. 1.23. What is the ratio of the Electricity production(% of total) of Russian Federation in 1997 to that in 1998?
Make the answer very short. 0.96. What is the ratio of the Electricity production(% of total) of East Asia (developing only) in 1997 to that in 1999?
Provide a short and direct response. 0.98. What is the ratio of the Electricity production(% of total) in Least developed countries in 1997 to that in 1999?
Make the answer very short. 1.17. What is the ratio of the Electricity production(% of total) of Portugal in 1997 to that in 1999?
Your answer should be compact. 1.08. What is the ratio of the Electricity production(% of total) in Russian Federation in 1997 to that in 1999?
Your answer should be compact. 0.99. What is the ratio of the Electricity production(% of total) of East Asia (developing only) in 1997 to that in 2000?
Your answer should be compact. 0.96. What is the ratio of the Electricity production(% of total) of Least developed countries in 1997 to that in 2000?
Make the answer very short. 1.11. What is the ratio of the Electricity production(% of total) in Portugal in 1997 to that in 2000?
Provide a short and direct response. 1.13. What is the ratio of the Electricity production(% of total) in Russian Federation in 1997 to that in 2000?
Ensure brevity in your answer.  0.94. What is the ratio of the Electricity production(% of total) in East Asia (developing only) in 1997 to that in 2001?
Your answer should be compact. 0.97. What is the ratio of the Electricity production(% of total) in Least developed countries in 1997 to that in 2001?
Your answer should be compact. 0.93. What is the ratio of the Electricity production(% of total) of Portugal in 1997 to that in 2001?
Provide a succinct answer. 1.29. What is the ratio of the Electricity production(% of total) of Russian Federation in 1997 to that in 2001?
Your answer should be very brief. 0.99. What is the ratio of the Electricity production(% of total) in East Asia (developing only) in 1997 to that in 2002?
Your response must be concise. 0.95. What is the ratio of the Electricity production(% of total) of Least developed countries in 1997 to that in 2002?
Provide a short and direct response. 0.14. What is the ratio of the Electricity production(% of total) of Portugal in 1997 to that in 2002?
Ensure brevity in your answer.  1.15. What is the ratio of the Electricity production(% of total) in Russian Federation in 1997 to that in 2002?
Your response must be concise. 0.98. What is the ratio of the Electricity production(% of total) in East Asia (developing only) in 1997 to that in 2003?
Give a very brief answer. 0.93. What is the ratio of the Electricity production(% of total) in Least developed countries in 1997 to that in 2003?
Ensure brevity in your answer.  0.15. What is the ratio of the Electricity production(% of total) in Portugal in 1997 to that in 2003?
Make the answer very short. 1.22. What is the ratio of the Electricity production(% of total) in Russian Federation in 1997 to that in 2003?
Your answer should be very brief. 1. What is the ratio of the Electricity production(% of total) in East Asia (developing only) in 1997 to that in 2004?
Offer a terse response. 0.93. What is the ratio of the Electricity production(% of total) of Least developed countries in 1997 to that in 2004?
Provide a short and direct response. 0.24. What is the ratio of the Electricity production(% of total) in Portugal in 1997 to that in 2004?
Offer a very short reply. 1.15. What is the ratio of the Electricity production(% of total) of Russian Federation in 1997 to that in 2004?
Your response must be concise. 1.09. What is the ratio of the Electricity production(% of total) in East Asia (developing only) in 1998 to that in 1999?
Offer a terse response. 0.97. What is the ratio of the Electricity production(% of total) in Least developed countries in 1998 to that in 1999?
Your response must be concise. 1.09. What is the ratio of the Electricity production(% of total) in Portugal in 1998 to that in 1999?
Offer a very short reply. 0.88. What is the ratio of the Electricity production(% of total) in Russian Federation in 1998 to that in 1999?
Offer a terse response. 1.03. What is the ratio of the Electricity production(% of total) of Least developed countries in 1998 to that in 2000?
Provide a short and direct response. 1.04. What is the ratio of the Electricity production(% of total) of Portugal in 1998 to that in 2000?
Make the answer very short. 0.91. What is the ratio of the Electricity production(% of total) in Russian Federation in 1998 to that in 2000?
Provide a succinct answer. 0.98. What is the ratio of the Electricity production(% of total) of East Asia (developing only) in 1998 to that in 2001?
Ensure brevity in your answer.  0.97. What is the ratio of the Electricity production(% of total) of Least developed countries in 1998 to that in 2001?
Offer a terse response. 0.87. What is the ratio of the Electricity production(% of total) of Portugal in 1998 to that in 2001?
Your answer should be compact. 1.05. What is the ratio of the Electricity production(% of total) in Russian Federation in 1998 to that in 2001?
Offer a terse response. 1.03. What is the ratio of the Electricity production(% of total) of East Asia (developing only) in 1998 to that in 2002?
Provide a short and direct response. 0.95. What is the ratio of the Electricity production(% of total) of Least developed countries in 1998 to that in 2002?
Provide a succinct answer. 0.13. What is the ratio of the Electricity production(% of total) of Portugal in 1998 to that in 2002?
Give a very brief answer. 0.93. What is the ratio of the Electricity production(% of total) of Russian Federation in 1998 to that in 2002?
Ensure brevity in your answer.  1.02. What is the ratio of the Electricity production(% of total) in East Asia (developing only) in 1998 to that in 2003?
Your response must be concise. 0.92. What is the ratio of the Electricity production(% of total) in Least developed countries in 1998 to that in 2003?
Provide a short and direct response. 0.14. What is the ratio of the Electricity production(% of total) in Russian Federation in 1998 to that in 2003?
Your answer should be compact. 1.04. What is the ratio of the Electricity production(% of total) in East Asia (developing only) in 1998 to that in 2004?
Keep it short and to the point. 0.93. What is the ratio of the Electricity production(% of total) of Least developed countries in 1998 to that in 2004?
Your answer should be compact. 0.22. What is the ratio of the Electricity production(% of total) in Portugal in 1998 to that in 2004?
Your response must be concise. 0.93. What is the ratio of the Electricity production(% of total) of Russian Federation in 1998 to that in 2004?
Keep it short and to the point. 1.13. What is the ratio of the Electricity production(% of total) of East Asia (developing only) in 1999 to that in 2000?
Ensure brevity in your answer.  0.98. What is the ratio of the Electricity production(% of total) of Least developed countries in 1999 to that in 2000?
Provide a succinct answer. 0.95. What is the ratio of the Electricity production(% of total) of Portugal in 1999 to that in 2000?
Offer a terse response. 1.04. What is the ratio of the Electricity production(% of total) in Russian Federation in 1999 to that in 2000?
Your answer should be compact. 0.95. What is the ratio of the Electricity production(% of total) in East Asia (developing only) in 1999 to that in 2001?
Keep it short and to the point. 1. What is the ratio of the Electricity production(% of total) in Least developed countries in 1999 to that in 2001?
Your answer should be compact. 0.8. What is the ratio of the Electricity production(% of total) in Portugal in 1999 to that in 2001?
Your answer should be compact. 1.19. What is the ratio of the Electricity production(% of total) of Russian Federation in 1999 to that in 2001?
Give a very brief answer. 1. What is the ratio of the Electricity production(% of total) in East Asia (developing only) in 1999 to that in 2002?
Offer a very short reply. 0.98. What is the ratio of the Electricity production(% of total) in Least developed countries in 1999 to that in 2002?
Make the answer very short. 0.12. What is the ratio of the Electricity production(% of total) of Portugal in 1999 to that in 2002?
Keep it short and to the point. 1.06. What is the ratio of the Electricity production(% of total) in Russian Federation in 1999 to that in 2002?
Provide a short and direct response. 1. What is the ratio of the Electricity production(% of total) of East Asia (developing only) in 1999 to that in 2003?
Provide a succinct answer. 0.95. What is the ratio of the Electricity production(% of total) in Least developed countries in 1999 to that in 2003?
Offer a very short reply. 0.12. What is the ratio of the Electricity production(% of total) in Portugal in 1999 to that in 2003?
Keep it short and to the point. 1.13. What is the ratio of the Electricity production(% of total) in Russian Federation in 1999 to that in 2003?
Ensure brevity in your answer.  1.01. What is the ratio of the Electricity production(% of total) in East Asia (developing only) in 1999 to that in 2004?
Offer a terse response. 0.96. What is the ratio of the Electricity production(% of total) in Least developed countries in 1999 to that in 2004?
Your answer should be very brief. 0.2. What is the ratio of the Electricity production(% of total) in Portugal in 1999 to that in 2004?
Provide a short and direct response. 1.06. What is the ratio of the Electricity production(% of total) in Russian Federation in 1999 to that in 2004?
Your answer should be very brief. 1.1. What is the ratio of the Electricity production(% of total) of East Asia (developing only) in 2000 to that in 2001?
Provide a succinct answer. 1.02. What is the ratio of the Electricity production(% of total) in Least developed countries in 2000 to that in 2001?
Your answer should be very brief. 0.84. What is the ratio of the Electricity production(% of total) in Portugal in 2000 to that in 2001?
Your answer should be very brief. 1.15. What is the ratio of the Electricity production(% of total) in Russian Federation in 2000 to that in 2001?
Give a very brief answer. 1.05. What is the ratio of the Electricity production(% of total) of Least developed countries in 2000 to that in 2002?
Offer a terse response. 0.12. What is the ratio of the Electricity production(% of total) in Portugal in 2000 to that in 2002?
Offer a terse response. 1.02. What is the ratio of the Electricity production(% of total) in Russian Federation in 2000 to that in 2002?
Make the answer very short. 1.04. What is the ratio of the Electricity production(% of total) of East Asia (developing only) in 2000 to that in 2003?
Give a very brief answer. 0.97. What is the ratio of the Electricity production(% of total) in Least developed countries in 2000 to that in 2003?
Your response must be concise. 0.13. What is the ratio of the Electricity production(% of total) in Portugal in 2000 to that in 2003?
Offer a terse response. 1.08. What is the ratio of the Electricity production(% of total) in Russian Federation in 2000 to that in 2003?
Give a very brief answer. 1.06. What is the ratio of the Electricity production(% of total) in East Asia (developing only) in 2000 to that in 2004?
Provide a short and direct response. 0.97. What is the ratio of the Electricity production(% of total) in Least developed countries in 2000 to that in 2004?
Ensure brevity in your answer.  0.21. What is the ratio of the Electricity production(% of total) of Portugal in 2000 to that in 2004?
Provide a succinct answer. 1.02. What is the ratio of the Electricity production(% of total) of Russian Federation in 2000 to that in 2004?
Offer a terse response. 1.16. What is the ratio of the Electricity production(% of total) of East Asia (developing only) in 2001 to that in 2002?
Make the answer very short. 0.98. What is the ratio of the Electricity production(% of total) of Least developed countries in 2001 to that in 2002?
Your response must be concise. 0.15. What is the ratio of the Electricity production(% of total) in Portugal in 2001 to that in 2002?
Offer a very short reply. 0.89. What is the ratio of the Electricity production(% of total) in East Asia (developing only) in 2001 to that in 2003?
Keep it short and to the point. 0.95. What is the ratio of the Electricity production(% of total) of Least developed countries in 2001 to that in 2003?
Provide a succinct answer. 0.16. What is the ratio of the Electricity production(% of total) of Portugal in 2001 to that in 2003?
Provide a succinct answer. 0.94. What is the ratio of the Electricity production(% of total) of Russian Federation in 2001 to that in 2003?
Give a very brief answer. 1.01. What is the ratio of the Electricity production(% of total) in East Asia (developing only) in 2001 to that in 2004?
Keep it short and to the point. 0.96. What is the ratio of the Electricity production(% of total) in Least developed countries in 2001 to that in 2004?
Offer a terse response. 0.25. What is the ratio of the Electricity production(% of total) in Portugal in 2001 to that in 2004?
Keep it short and to the point. 0.89. What is the ratio of the Electricity production(% of total) in Russian Federation in 2001 to that in 2004?
Provide a short and direct response. 1.1. What is the ratio of the Electricity production(% of total) in East Asia (developing only) in 2002 to that in 2003?
Provide a succinct answer. 0.97. What is the ratio of the Electricity production(% of total) of Least developed countries in 2002 to that in 2003?
Provide a succinct answer. 1.07. What is the ratio of the Electricity production(% of total) of Portugal in 2002 to that in 2003?
Offer a terse response. 1.07. What is the ratio of the Electricity production(% of total) in Russian Federation in 2002 to that in 2003?
Give a very brief answer. 1.02. What is the ratio of the Electricity production(% of total) in East Asia (developing only) in 2002 to that in 2004?
Your answer should be compact. 0.98. What is the ratio of the Electricity production(% of total) of Least developed countries in 2002 to that in 2004?
Your response must be concise. 1.73. What is the ratio of the Electricity production(% of total) of Portugal in 2002 to that in 2004?
Ensure brevity in your answer.  1.01. What is the ratio of the Electricity production(% of total) of Russian Federation in 2002 to that in 2004?
Keep it short and to the point. 1.11. What is the ratio of the Electricity production(% of total) in East Asia (developing only) in 2003 to that in 2004?
Offer a very short reply. 1.01. What is the ratio of the Electricity production(% of total) of Least developed countries in 2003 to that in 2004?
Provide a short and direct response. 1.62. What is the ratio of the Electricity production(% of total) in Portugal in 2003 to that in 2004?
Offer a very short reply. 0.94. What is the ratio of the Electricity production(% of total) of Russian Federation in 2003 to that in 2004?
Ensure brevity in your answer.  1.09. What is the difference between the highest and the second highest Electricity production(% of total) in East Asia (developing only)?
Provide a short and direct response. 0.6. What is the difference between the highest and the second highest Electricity production(% of total) in Least developed countries?
Ensure brevity in your answer.  0.05. What is the difference between the highest and the second highest Electricity production(% of total) of Portugal?
Your answer should be very brief. 2.96. What is the difference between the highest and the second highest Electricity production(% of total) of Russian Federation?
Provide a succinct answer. 0.38. What is the difference between the highest and the lowest Electricity production(% of total) in East Asia (developing only)?
Keep it short and to the point. 5.58. What is the difference between the highest and the lowest Electricity production(% of total) in Least developed countries?
Offer a terse response. 0.73. What is the difference between the highest and the lowest Electricity production(% of total) in Portugal?
Offer a terse response. 8.7. What is the difference between the highest and the lowest Electricity production(% of total) in Russian Federation?
Your answer should be compact. 2.68. 